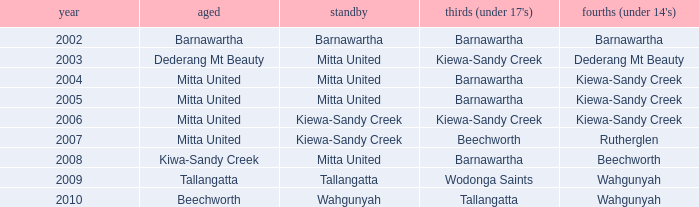In barnawartha, which thirds (for those under 17) have a reserve? Barnawartha. Can you parse all the data within this table? {'header': ['year', 'aged', 'standby', "thirds (under 17's)", "fourths (under 14's)"], 'rows': [['2002', 'Barnawartha', 'Barnawartha', 'Barnawartha', 'Barnawartha'], ['2003', 'Dederang Mt Beauty', 'Mitta United', 'Kiewa-Sandy Creek', 'Dederang Mt Beauty'], ['2004', 'Mitta United', 'Mitta United', 'Barnawartha', 'Kiewa-Sandy Creek'], ['2005', 'Mitta United', 'Mitta United', 'Barnawartha', 'Kiewa-Sandy Creek'], ['2006', 'Mitta United', 'Kiewa-Sandy Creek', 'Kiewa-Sandy Creek', 'Kiewa-Sandy Creek'], ['2007', 'Mitta United', 'Kiewa-Sandy Creek', 'Beechworth', 'Rutherglen'], ['2008', 'Kiwa-Sandy Creek', 'Mitta United', 'Barnawartha', 'Beechworth'], ['2009', 'Tallangatta', 'Tallangatta', 'Wodonga Saints', 'Wahgunyah'], ['2010', 'Beechworth', 'Wahgunyah', 'Tallangatta', 'Wahgunyah']]} 